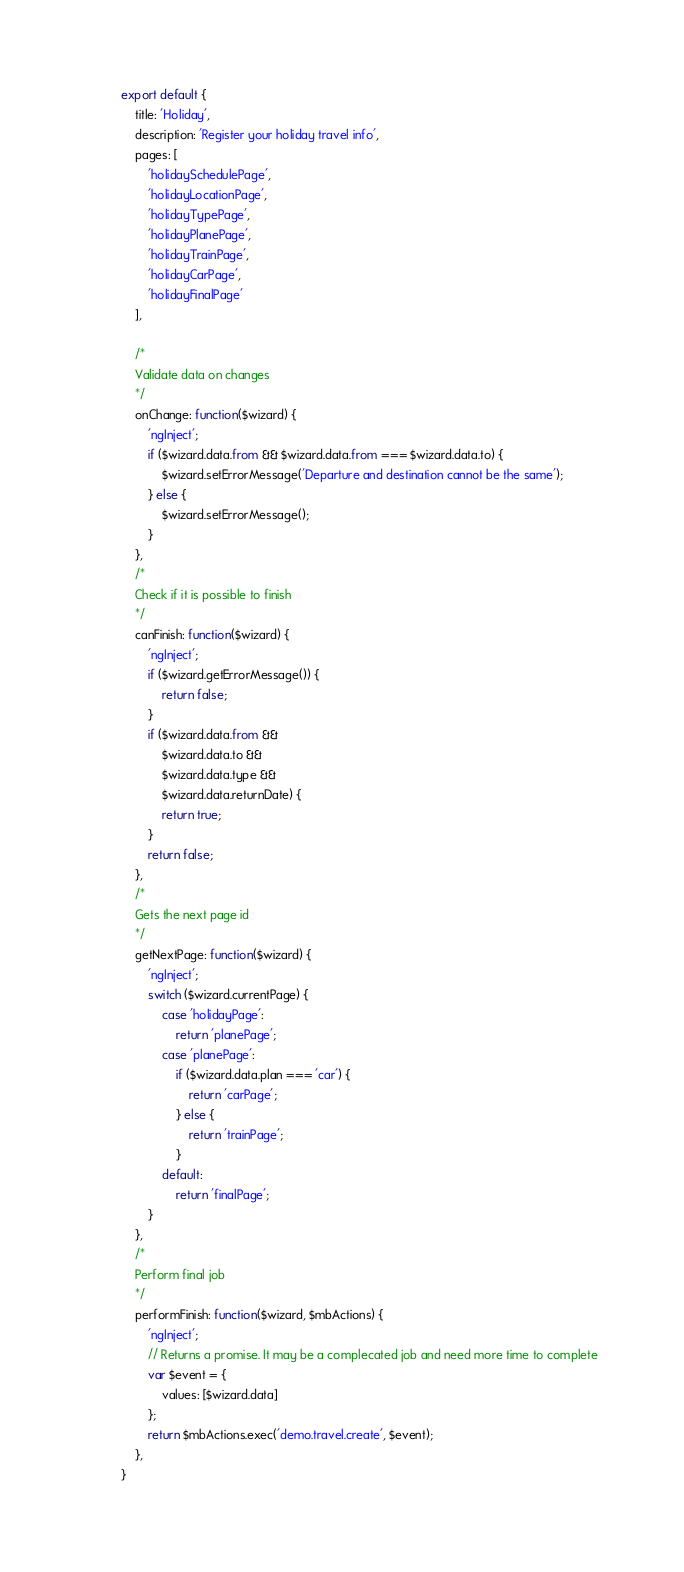Convert code to text. <code><loc_0><loc_0><loc_500><loc_500><_JavaScript_>

export default {
	title: 'Holiday',
	description: 'Register your holiday travel info',
	pages: [
		'holidaySchedulePage',
		'holidayLocationPage',
		'holidayTypePage',
		'holidayPlanePage',
		'holidayTrainPage',
		'holidayCarPage',
		'holidayFinalPage'
	],

	/*
	Validate data on changes
	*/
	onChange: function($wizard) {
		'ngInject';
		if ($wizard.data.from && $wizard.data.from === $wizard.data.to) {
			$wizard.setErrorMessage('Departure and destination cannot be the same');
		} else {
			$wizard.setErrorMessage();
		}
	},
	/*
	Check if it is possible to finish
	*/
	canFinish: function($wizard) {
		'ngInject';
		if ($wizard.getErrorMessage()) {
			return false;
		}
		if ($wizard.data.from &&
			$wizard.data.to &&
			$wizard.data.type &&
			$wizard.data.returnDate) {
			return true;
		}
		return false;
	},
	/*
	Gets the next page id
	*/
	getNextPage: function($wizard) {
		'ngInject';
		switch ($wizard.currentPage) {
			case 'holidayPage':
				return 'planePage';
			case 'planePage':
				if ($wizard.data.plan === 'car') {
					return 'carPage';
				} else {
					return 'trainPage';
				}
			default:
				return 'finalPage';
		}
	},
	/*
	Perform final job
	*/
	performFinish: function($wizard, $mbActions) {
		'ngInject';
		// Returns a promise. It may be a complecated job and need more time to complete
		var $event = {
			values: [$wizard.data]
		};
		return $mbActions.exec('demo.travel.create', $event);
	},
}




</code> 